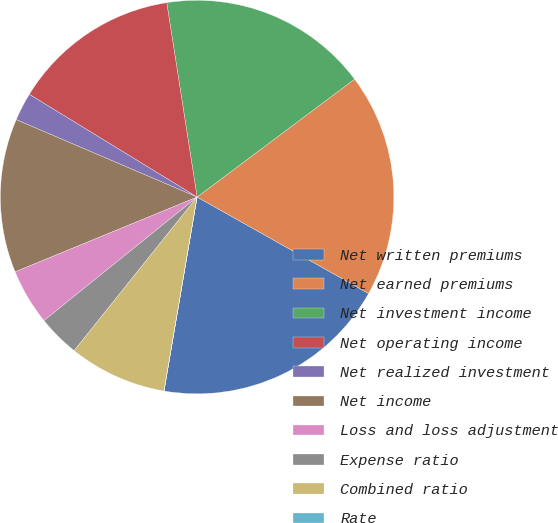Convert chart. <chart><loc_0><loc_0><loc_500><loc_500><pie_chart><fcel>Net written premiums<fcel>Net earned premiums<fcel>Net investment income<fcel>Net operating income<fcel>Net realized investment<fcel>Net income<fcel>Loss and loss adjustment<fcel>Expense ratio<fcel>Combined ratio<fcel>Rate<nl><fcel>19.53%<fcel>18.38%<fcel>17.24%<fcel>13.79%<fcel>2.31%<fcel>12.64%<fcel>4.6%<fcel>3.45%<fcel>8.05%<fcel>0.01%<nl></chart> 